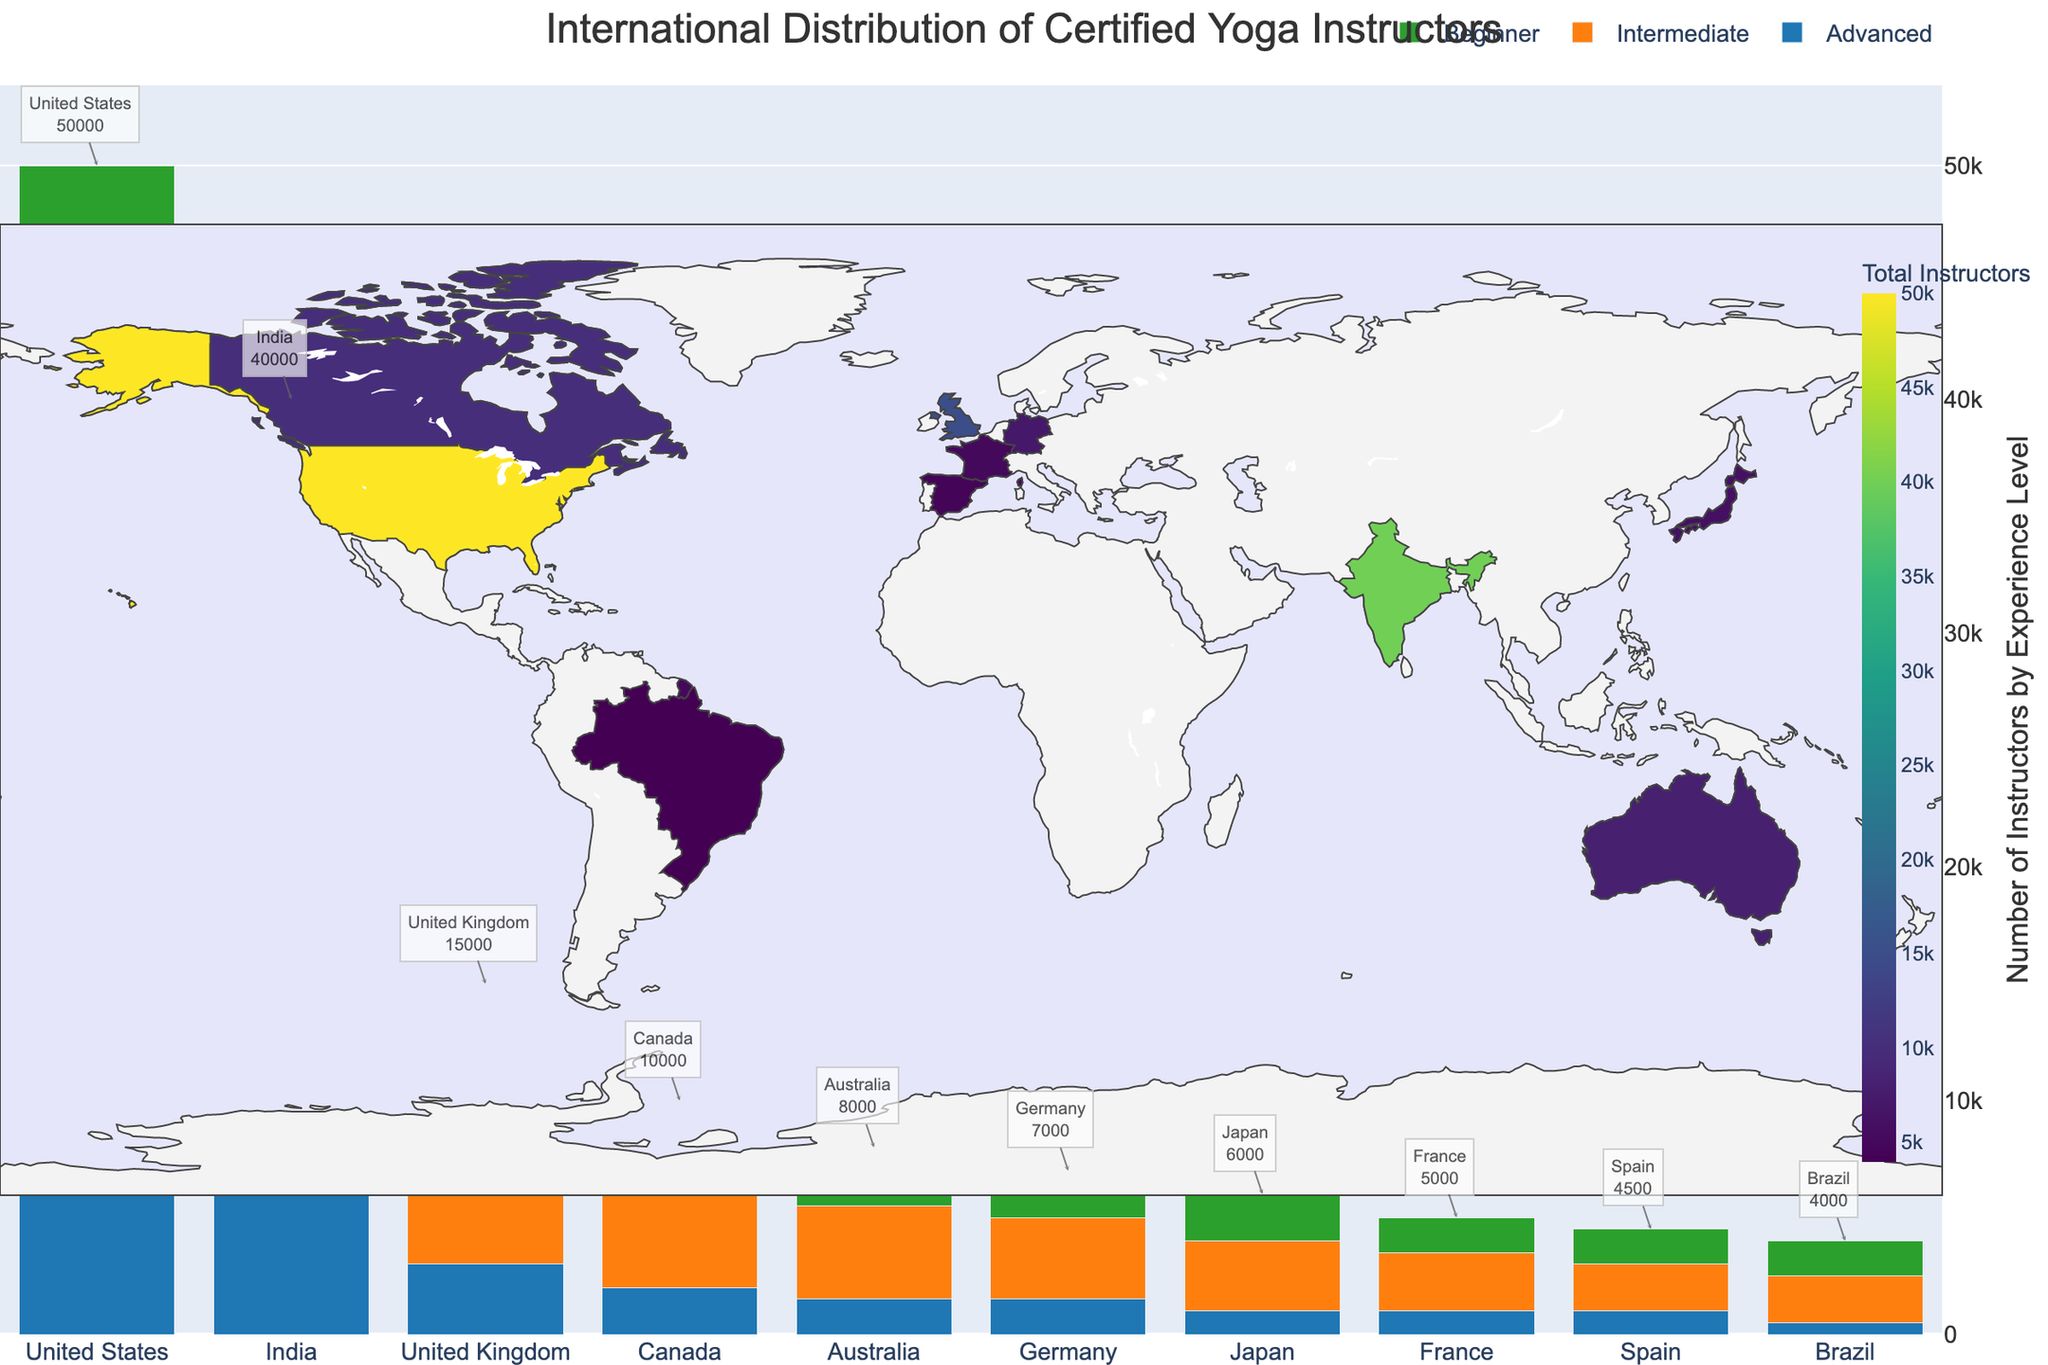What is the title of the figure? The title is typically displayed at the top of the figure and summarizes the content of the plot.
Answer: International Distribution of Certified Yoga Instructors Which country has the highest number of certified yoga instructors? Look at the color intensity on the choropleth map and the annotations; the United States has the highest number with 50,000 instructors.
Answer: United States What type of yoga specialization is most popular in India? Check the data for each specialization in India; Vinyasa has the highest number with 15,000 instructors.
Answer: Vinyasa How many advanced-level instructors does Australia have? Refer to the "Advanced" category in the data table for Australia; there are 1,500 advanced instructors.
Answer: 1,500 Which country has the fewest total certified yoga instructors? Check the countries with the lightest color shade on the choropleth map; Brazil has the fewest with 4,000 instructors.
Answer: Brazil What is the total number of instructors in the United Kingdom and Canada combined? Sum the total instructors in the United Kingdom (15,000) and Canada (10,000); 15,000 + 10,000 = 25,000.
Answer: 25,000 How does the number of intermediate instructors in Germany compare to that in Japan? Look at the intermediate category in the data table; Germany has 3,500 instructors, while Japan has 3,000. Germany has more.
Answer: Germany Which country has a greater proportion of beginner instructors, Spain or France? Calculate the proportion of beginner instructors (Beginner / Total_Instructors) for Spain (1,500/4,500 = 0.33) and France (1,500/5,000 = 0.30); Spain has a greater proportion.
Answer: Spain What is the difference between the number of Hatha instructors in Canada and Japan? Subtract the number of Hatha instructors in Canada (3,000) from those in Japan (1,500); 3,000 - 1,500 = 1,500.
Answer: 1,500 